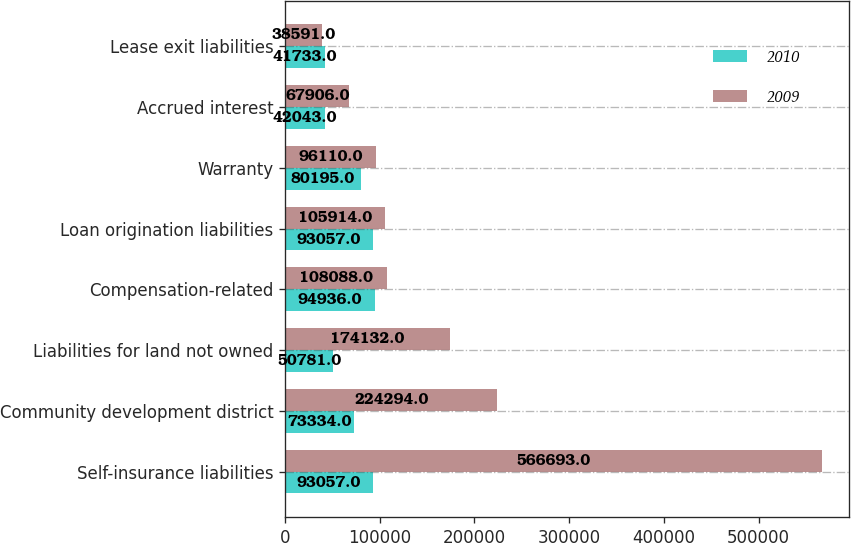<chart> <loc_0><loc_0><loc_500><loc_500><stacked_bar_chart><ecel><fcel>Self-insurance liabilities<fcel>Community development district<fcel>Liabilities for land not owned<fcel>Compensation-related<fcel>Loan origination liabilities<fcel>Warranty<fcel>Accrued interest<fcel>Lease exit liabilities<nl><fcel>2010<fcel>93057<fcel>73334<fcel>50781<fcel>94936<fcel>93057<fcel>80195<fcel>42043<fcel>41733<nl><fcel>2009<fcel>566693<fcel>224294<fcel>174132<fcel>108088<fcel>105914<fcel>96110<fcel>67906<fcel>38591<nl></chart> 